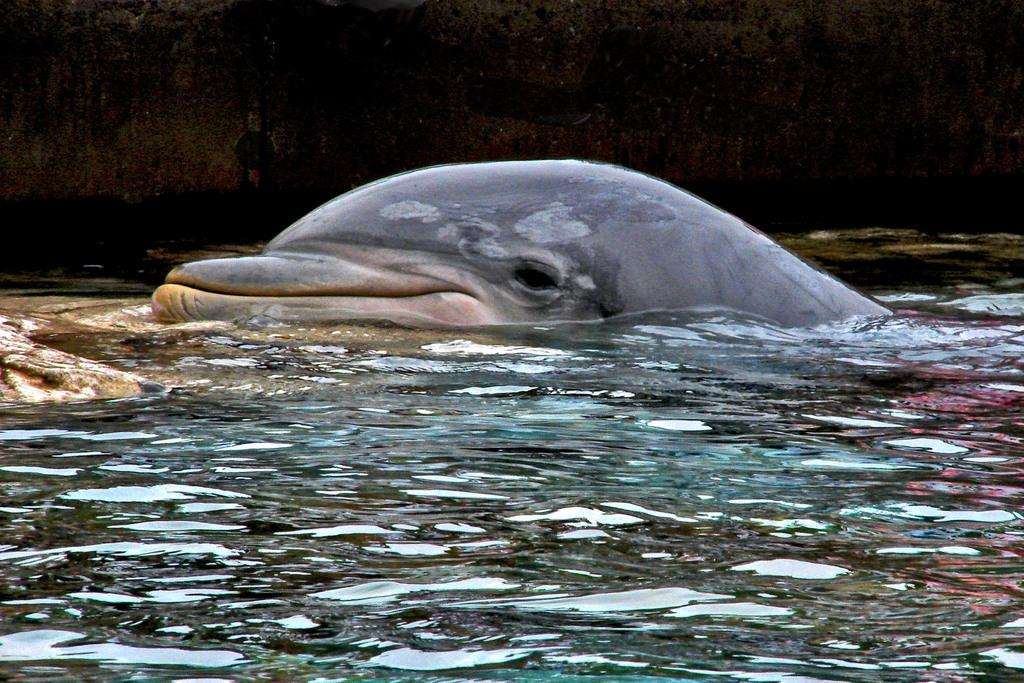What is the main subject in the center of the image? There is a dolphin in the center of the image. Where is the dolphin located? The dolphin is in the water. What can be seen at the bottom side of the image? There is water visible at the bottom side of the image. What type of bucket is floating next to the dolphin in the image? There is no bucket present in the image; it only features a dolphin in the water. Can you see a scarecrow in the sky in the image? There is no sky or scarecrow present in the image; it only shows a dolphin in the water. 